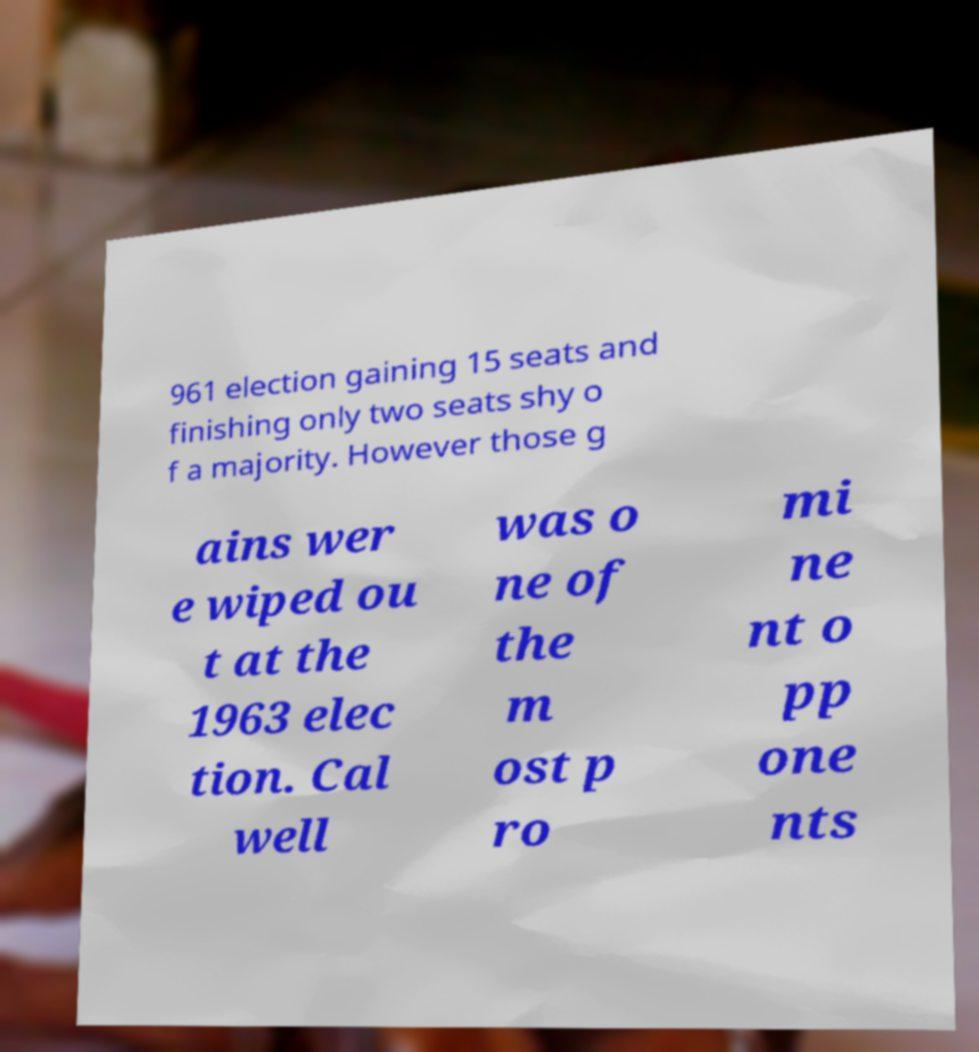I need the written content from this picture converted into text. Can you do that? 961 election gaining 15 seats and finishing only two seats shy o f a majority. However those g ains wer e wiped ou t at the 1963 elec tion. Cal well was o ne of the m ost p ro mi ne nt o pp one nts 